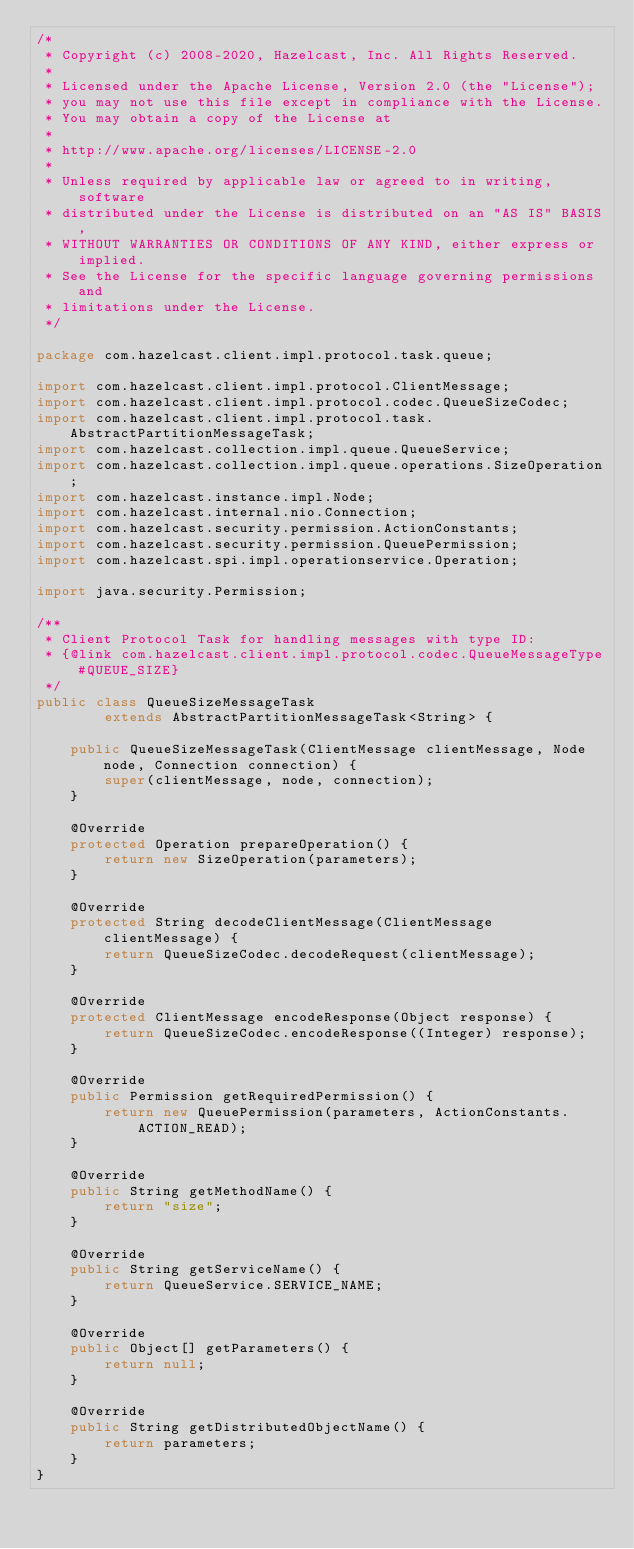<code> <loc_0><loc_0><loc_500><loc_500><_Java_>/*
 * Copyright (c) 2008-2020, Hazelcast, Inc. All Rights Reserved.
 *
 * Licensed under the Apache License, Version 2.0 (the "License");
 * you may not use this file except in compliance with the License.
 * You may obtain a copy of the License at
 *
 * http://www.apache.org/licenses/LICENSE-2.0
 *
 * Unless required by applicable law or agreed to in writing, software
 * distributed under the License is distributed on an "AS IS" BASIS,
 * WITHOUT WARRANTIES OR CONDITIONS OF ANY KIND, either express or implied.
 * See the License for the specific language governing permissions and
 * limitations under the License.
 */

package com.hazelcast.client.impl.protocol.task.queue;

import com.hazelcast.client.impl.protocol.ClientMessage;
import com.hazelcast.client.impl.protocol.codec.QueueSizeCodec;
import com.hazelcast.client.impl.protocol.task.AbstractPartitionMessageTask;
import com.hazelcast.collection.impl.queue.QueueService;
import com.hazelcast.collection.impl.queue.operations.SizeOperation;
import com.hazelcast.instance.impl.Node;
import com.hazelcast.internal.nio.Connection;
import com.hazelcast.security.permission.ActionConstants;
import com.hazelcast.security.permission.QueuePermission;
import com.hazelcast.spi.impl.operationservice.Operation;

import java.security.Permission;

/**
 * Client Protocol Task for handling messages with type ID:
 * {@link com.hazelcast.client.impl.protocol.codec.QueueMessageType#QUEUE_SIZE}
 */
public class QueueSizeMessageTask
        extends AbstractPartitionMessageTask<String> {

    public QueueSizeMessageTask(ClientMessage clientMessage, Node node, Connection connection) {
        super(clientMessage, node, connection);
    }

    @Override
    protected Operation prepareOperation() {
        return new SizeOperation(parameters);
    }

    @Override
    protected String decodeClientMessage(ClientMessage clientMessage) {
        return QueueSizeCodec.decodeRequest(clientMessage);
    }

    @Override
    protected ClientMessage encodeResponse(Object response) {
        return QueueSizeCodec.encodeResponse((Integer) response);
    }

    @Override
    public Permission getRequiredPermission() {
        return new QueuePermission(parameters, ActionConstants.ACTION_READ);
    }

    @Override
    public String getMethodName() {
        return "size";
    }

    @Override
    public String getServiceName() {
        return QueueService.SERVICE_NAME;
    }

    @Override
    public Object[] getParameters() {
        return null;
    }

    @Override
    public String getDistributedObjectName() {
        return parameters;
    }
}
</code> 